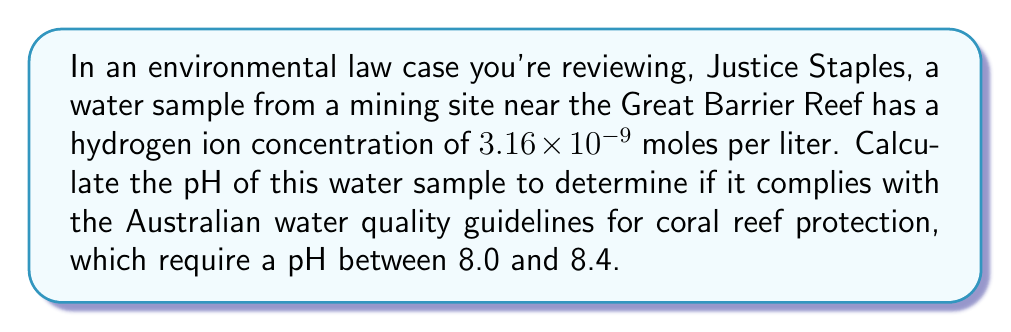Could you help me with this problem? To solve this problem, we'll use the definition of pH and the properties of logarithms:

1) The pH is defined as the negative logarithm (base 10) of the hydrogen ion concentration:

   $$pH = -\log_{10}[H^+]$$

2) We're given that $[H^+] = 3.16 \times 10^{-9}$ moles/L

3) Substituting this into the pH equation:

   $$pH = -\log_{10}(3.16 \times 10^{-9})$$

4) Using the properties of logarithms, we can split this into two parts:

   $$pH = -(\log_{10}(3.16) + \log_{10}(10^{-9}))$$

5) $\log_{10}(10^{-9}) = -9$, so:

   $$pH = -(\log_{10}(3.16) - 9)$$

6) $\log_{10}(3.16) \approx 0.4997$

7) Therefore:

   $$pH = -0.4997 + 9 = 8.5003$$

8) Rounding to two decimal places: pH = 8.50

This pH is slightly above the upper limit of 8.4 specified in the Australian water quality guidelines for coral reef protection.
Answer: The pH of the water sample is 8.50, which exceeds the upper limit of the Australian water quality guidelines for coral reef protection. 